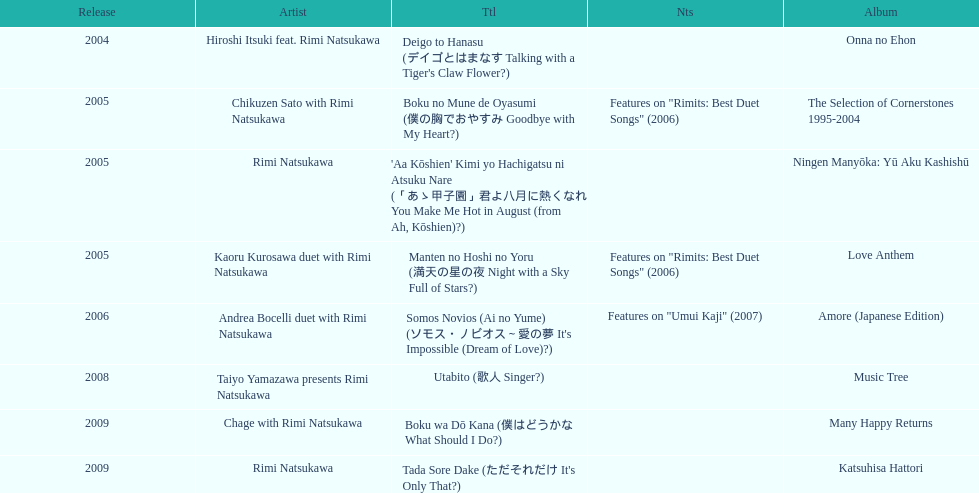What is the last title released? 2009. 